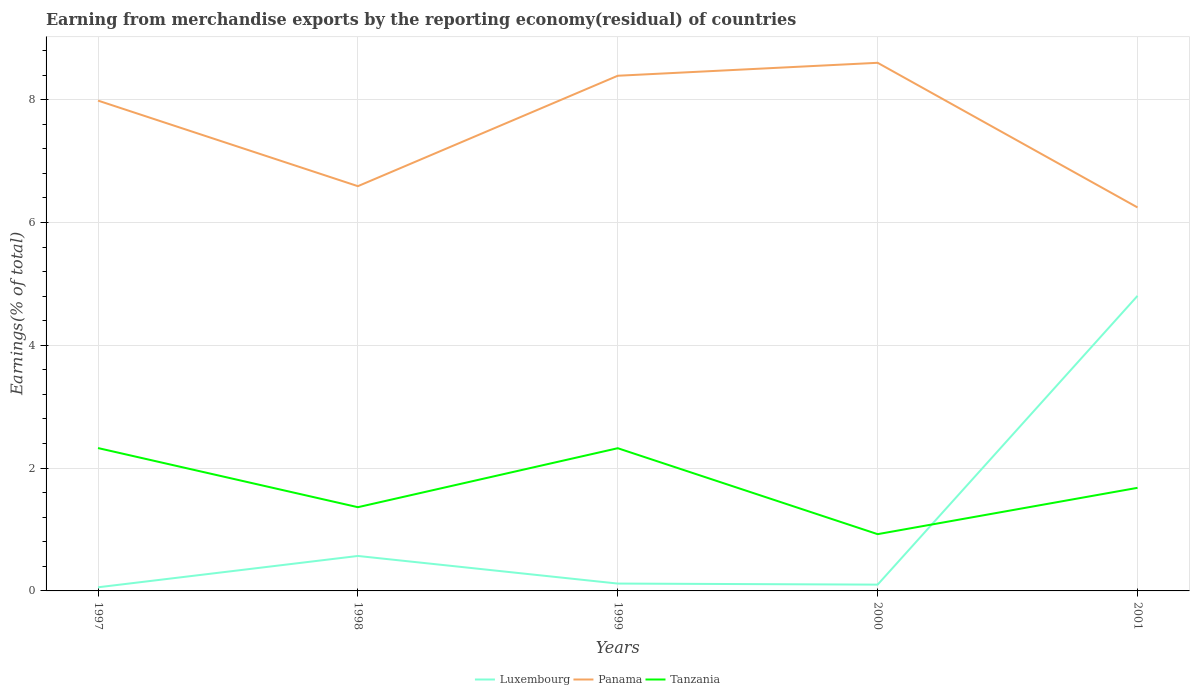Does the line corresponding to Panama intersect with the line corresponding to Tanzania?
Your answer should be very brief. No. Across all years, what is the maximum percentage of amount earned from merchandise exports in Luxembourg?
Give a very brief answer. 0.06. In which year was the percentage of amount earned from merchandise exports in Panama maximum?
Give a very brief answer. 2001. What is the total percentage of amount earned from merchandise exports in Panama in the graph?
Offer a terse response. 2.36. What is the difference between the highest and the second highest percentage of amount earned from merchandise exports in Tanzania?
Your answer should be compact. 1.4. What is the difference between the highest and the lowest percentage of amount earned from merchandise exports in Luxembourg?
Make the answer very short. 1. Is the percentage of amount earned from merchandise exports in Panama strictly greater than the percentage of amount earned from merchandise exports in Tanzania over the years?
Your response must be concise. No. Are the values on the major ticks of Y-axis written in scientific E-notation?
Provide a succinct answer. No. Does the graph contain any zero values?
Your answer should be compact. No. Where does the legend appear in the graph?
Give a very brief answer. Bottom center. What is the title of the graph?
Provide a succinct answer. Earning from merchandise exports by the reporting economy(residual) of countries. What is the label or title of the Y-axis?
Make the answer very short. Earnings(% of total). What is the Earnings(% of total) in Luxembourg in 1997?
Provide a short and direct response. 0.06. What is the Earnings(% of total) in Panama in 1997?
Provide a succinct answer. 7.99. What is the Earnings(% of total) of Tanzania in 1997?
Give a very brief answer. 2.33. What is the Earnings(% of total) of Luxembourg in 1998?
Ensure brevity in your answer.  0.57. What is the Earnings(% of total) of Panama in 1998?
Make the answer very short. 6.59. What is the Earnings(% of total) of Tanzania in 1998?
Make the answer very short. 1.36. What is the Earnings(% of total) in Luxembourg in 1999?
Keep it short and to the point. 0.12. What is the Earnings(% of total) of Panama in 1999?
Your answer should be very brief. 8.39. What is the Earnings(% of total) of Tanzania in 1999?
Your answer should be very brief. 2.32. What is the Earnings(% of total) in Luxembourg in 2000?
Offer a terse response. 0.1. What is the Earnings(% of total) of Panama in 2000?
Your response must be concise. 8.6. What is the Earnings(% of total) of Tanzania in 2000?
Make the answer very short. 0.92. What is the Earnings(% of total) of Luxembourg in 2001?
Your answer should be very brief. 4.81. What is the Earnings(% of total) of Panama in 2001?
Give a very brief answer. 6.25. What is the Earnings(% of total) in Tanzania in 2001?
Keep it short and to the point. 1.68. Across all years, what is the maximum Earnings(% of total) of Luxembourg?
Your answer should be very brief. 4.81. Across all years, what is the maximum Earnings(% of total) of Panama?
Your answer should be very brief. 8.6. Across all years, what is the maximum Earnings(% of total) of Tanzania?
Make the answer very short. 2.33. Across all years, what is the minimum Earnings(% of total) in Luxembourg?
Keep it short and to the point. 0.06. Across all years, what is the minimum Earnings(% of total) in Panama?
Your response must be concise. 6.25. Across all years, what is the minimum Earnings(% of total) of Tanzania?
Ensure brevity in your answer.  0.92. What is the total Earnings(% of total) of Luxembourg in the graph?
Your answer should be compact. 5.66. What is the total Earnings(% of total) in Panama in the graph?
Your response must be concise. 37.81. What is the total Earnings(% of total) of Tanzania in the graph?
Provide a short and direct response. 8.62. What is the difference between the Earnings(% of total) of Luxembourg in 1997 and that in 1998?
Ensure brevity in your answer.  -0.51. What is the difference between the Earnings(% of total) in Panama in 1997 and that in 1998?
Offer a very short reply. 1.39. What is the difference between the Earnings(% of total) in Tanzania in 1997 and that in 1998?
Your answer should be compact. 0.96. What is the difference between the Earnings(% of total) in Luxembourg in 1997 and that in 1999?
Your response must be concise. -0.06. What is the difference between the Earnings(% of total) of Panama in 1997 and that in 1999?
Offer a very short reply. -0.4. What is the difference between the Earnings(% of total) of Tanzania in 1997 and that in 1999?
Give a very brief answer. 0. What is the difference between the Earnings(% of total) in Luxembourg in 1997 and that in 2000?
Provide a short and direct response. -0.04. What is the difference between the Earnings(% of total) in Panama in 1997 and that in 2000?
Keep it short and to the point. -0.62. What is the difference between the Earnings(% of total) of Tanzania in 1997 and that in 2000?
Make the answer very short. 1.4. What is the difference between the Earnings(% of total) of Luxembourg in 1997 and that in 2001?
Your answer should be very brief. -4.75. What is the difference between the Earnings(% of total) in Panama in 1997 and that in 2001?
Your answer should be compact. 1.74. What is the difference between the Earnings(% of total) of Tanzania in 1997 and that in 2001?
Provide a succinct answer. 0.65. What is the difference between the Earnings(% of total) in Luxembourg in 1998 and that in 1999?
Your answer should be compact. 0.45. What is the difference between the Earnings(% of total) of Panama in 1998 and that in 1999?
Ensure brevity in your answer.  -1.8. What is the difference between the Earnings(% of total) of Tanzania in 1998 and that in 1999?
Your answer should be very brief. -0.96. What is the difference between the Earnings(% of total) of Luxembourg in 1998 and that in 2000?
Offer a very short reply. 0.47. What is the difference between the Earnings(% of total) of Panama in 1998 and that in 2000?
Offer a terse response. -2.01. What is the difference between the Earnings(% of total) in Tanzania in 1998 and that in 2000?
Offer a terse response. 0.44. What is the difference between the Earnings(% of total) of Luxembourg in 1998 and that in 2001?
Provide a succinct answer. -4.24. What is the difference between the Earnings(% of total) in Panama in 1998 and that in 2001?
Give a very brief answer. 0.35. What is the difference between the Earnings(% of total) of Tanzania in 1998 and that in 2001?
Offer a terse response. -0.32. What is the difference between the Earnings(% of total) in Luxembourg in 1999 and that in 2000?
Give a very brief answer. 0.02. What is the difference between the Earnings(% of total) of Panama in 1999 and that in 2000?
Your answer should be compact. -0.21. What is the difference between the Earnings(% of total) of Tanzania in 1999 and that in 2000?
Ensure brevity in your answer.  1.4. What is the difference between the Earnings(% of total) of Luxembourg in 1999 and that in 2001?
Provide a short and direct response. -4.69. What is the difference between the Earnings(% of total) in Panama in 1999 and that in 2001?
Make the answer very short. 2.14. What is the difference between the Earnings(% of total) in Tanzania in 1999 and that in 2001?
Offer a very short reply. 0.65. What is the difference between the Earnings(% of total) of Luxembourg in 2000 and that in 2001?
Give a very brief answer. -4.7. What is the difference between the Earnings(% of total) of Panama in 2000 and that in 2001?
Your answer should be very brief. 2.36. What is the difference between the Earnings(% of total) in Tanzania in 2000 and that in 2001?
Your answer should be very brief. -0.75. What is the difference between the Earnings(% of total) in Luxembourg in 1997 and the Earnings(% of total) in Panama in 1998?
Your answer should be compact. -6.53. What is the difference between the Earnings(% of total) in Luxembourg in 1997 and the Earnings(% of total) in Tanzania in 1998?
Ensure brevity in your answer.  -1.3. What is the difference between the Earnings(% of total) in Panama in 1997 and the Earnings(% of total) in Tanzania in 1998?
Your answer should be very brief. 6.62. What is the difference between the Earnings(% of total) of Luxembourg in 1997 and the Earnings(% of total) of Panama in 1999?
Provide a short and direct response. -8.33. What is the difference between the Earnings(% of total) in Luxembourg in 1997 and the Earnings(% of total) in Tanzania in 1999?
Offer a very short reply. -2.27. What is the difference between the Earnings(% of total) in Panama in 1997 and the Earnings(% of total) in Tanzania in 1999?
Your response must be concise. 5.66. What is the difference between the Earnings(% of total) in Luxembourg in 1997 and the Earnings(% of total) in Panama in 2000?
Give a very brief answer. -8.54. What is the difference between the Earnings(% of total) in Luxembourg in 1997 and the Earnings(% of total) in Tanzania in 2000?
Offer a terse response. -0.87. What is the difference between the Earnings(% of total) in Panama in 1997 and the Earnings(% of total) in Tanzania in 2000?
Give a very brief answer. 7.06. What is the difference between the Earnings(% of total) of Luxembourg in 1997 and the Earnings(% of total) of Panama in 2001?
Offer a terse response. -6.19. What is the difference between the Earnings(% of total) of Luxembourg in 1997 and the Earnings(% of total) of Tanzania in 2001?
Ensure brevity in your answer.  -1.62. What is the difference between the Earnings(% of total) in Panama in 1997 and the Earnings(% of total) in Tanzania in 2001?
Your answer should be very brief. 6.31. What is the difference between the Earnings(% of total) of Luxembourg in 1998 and the Earnings(% of total) of Panama in 1999?
Ensure brevity in your answer.  -7.82. What is the difference between the Earnings(% of total) in Luxembourg in 1998 and the Earnings(% of total) in Tanzania in 1999?
Give a very brief answer. -1.75. What is the difference between the Earnings(% of total) in Panama in 1998 and the Earnings(% of total) in Tanzania in 1999?
Your answer should be very brief. 4.27. What is the difference between the Earnings(% of total) of Luxembourg in 1998 and the Earnings(% of total) of Panama in 2000?
Ensure brevity in your answer.  -8.03. What is the difference between the Earnings(% of total) in Luxembourg in 1998 and the Earnings(% of total) in Tanzania in 2000?
Make the answer very short. -0.36. What is the difference between the Earnings(% of total) of Panama in 1998 and the Earnings(% of total) of Tanzania in 2000?
Offer a very short reply. 5.67. What is the difference between the Earnings(% of total) of Luxembourg in 1998 and the Earnings(% of total) of Panama in 2001?
Your answer should be very brief. -5.68. What is the difference between the Earnings(% of total) of Luxembourg in 1998 and the Earnings(% of total) of Tanzania in 2001?
Ensure brevity in your answer.  -1.11. What is the difference between the Earnings(% of total) in Panama in 1998 and the Earnings(% of total) in Tanzania in 2001?
Keep it short and to the point. 4.91. What is the difference between the Earnings(% of total) of Luxembourg in 1999 and the Earnings(% of total) of Panama in 2000?
Your response must be concise. -8.48. What is the difference between the Earnings(% of total) of Luxembourg in 1999 and the Earnings(% of total) of Tanzania in 2000?
Provide a short and direct response. -0.8. What is the difference between the Earnings(% of total) in Panama in 1999 and the Earnings(% of total) in Tanzania in 2000?
Ensure brevity in your answer.  7.47. What is the difference between the Earnings(% of total) of Luxembourg in 1999 and the Earnings(% of total) of Panama in 2001?
Your answer should be very brief. -6.13. What is the difference between the Earnings(% of total) of Luxembourg in 1999 and the Earnings(% of total) of Tanzania in 2001?
Ensure brevity in your answer.  -1.56. What is the difference between the Earnings(% of total) of Panama in 1999 and the Earnings(% of total) of Tanzania in 2001?
Offer a very short reply. 6.71. What is the difference between the Earnings(% of total) in Luxembourg in 2000 and the Earnings(% of total) in Panama in 2001?
Your response must be concise. -6.14. What is the difference between the Earnings(% of total) in Luxembourg in 2000 and the Earnings(% of total) in Tanzania in 2001?
Provide a short and direct response. -1.58. What is the difference between the Earnings(% of total) of Panama in 2000 and the Earnings(% of total) of Tanzania in 2001?
Offer a very short reply. 6.92. What is the average Earnings(% of total) in Luxembourg per year?
Provide a succinct answer. 1.13. What is the average Earnings(% of total) of Panama per year?
Make the answer very short. 7.56. What is the average Earnings(% of total) in Tanzania per year?
Provide a succinct answer. 1.72. In the year 1997, what is the difference between the Earnings(% of total) in Luxembourg and Earnings(% of total) in Panama?
Give a very brief answer. -7.93. In the year 1997, what is the difference between the Earnings(% of total) of Luxembourg and Earnings(% of total) of Tanzania?
Provide a short and direct response. -2.27. In the year 1997, what is the difference between the Earnings(% of total) of Panama and Earnings(% of total) of Tanzania?
Give a very brief answer. 5.66. In the year 1998, what is the difference between the Earnings(% of total) of Luxembourg and Earnings(% of total) of Panama?
Your response must be concise. -6.02. In the year 1998, what is the difference between the Earnings(% of total) of Luxembourg and Earnings(% of total) of Tanzania?
Offer a terse response. -0.79. In the year 1998, what is the difference between the Earnings(% of total) in Panama and Earnings(% of total) in Tanzania?
Your response must be concise. 5.23. In the year 1999, what is the difference between the Earnings(% of total) of Luxembourg and Earnings(% of total) of Panama?
Your response must be concise. -8.27. In the year 1999, what is the difference between the Earnings(% of total) in Luxembourg and Earnings(% of total) in Tanzania?
Keep it short and to the point. -2.2. In the year 1999, what is the difference between the Earnings(% of total) of Panama and Earnings(% of total) of Tanzania?
Your response must be concise. 6.07. In the year 2000, what is the difference between the Earnings(% of total) of Luxembourg and Earnings(% of total) of Panama?
Provide a short and direct response. -8.5. In the year 2000, what is the difference between the Earnings(% of total) of Luxembourg and Earnings(% of total) of Tanzania?
Offer a terse response. -0.82. In the year 2000, what is the difference between the Earnings(% of total) in Panama and Earnings(% of total) in Tanzania?
Give a very brief answer. 7.68. In the year 2001, what is the difference between the Earnings(% of total) in Luxembourg and Earnings(% of total) in Panama?
Ensure brevity in your answer.  -1.44. In the year 2001, what is the difference between the Earnings(% of total) of Luxembourg and Earnings(% of total) of Tanzania?
Your answer should be very brief. 3.13. In the year 2001, what is the difference between the Earnings(% of total) of Panama and Earnings(% of total) of Tanzania?
Give a very brief answer. 4.57. What is the ratio of the Earnings(% of total) of Luxembourg in 1997 to that in 1998?
Your answer should be compact. 0.1. What is the ratio of the Earnings(% of total) in Panama in 1997 to that in 1998?
Offer a terse response. 1.21. What is the ratio of the Earnings(% of total) of Tanzania in 1997 to that in 1998?
Offer a terse response. 1.71. What is the ratio of the Earnings(% of total) of Luxembourg in 1997 to that in 1999?
Provide a short and direct response. 0.49. What is the ratio of the Earnings(% of total) in Panama in 1997 to that in 1999?
Your answer should be compact. 0.95. What is the ratio of the Earnings(% of total) in Tanzania in 1997 to that in 1999?
Offer a very short reply. 1. What is the ratio of the Earnings(% of total) of Luxembourg in 1997 to that in 2000?
Your response must be concise. 0.58. What is the ratio of the Earnings(% of total) in Panama in 1997 to that in 2000?
Your response must be concise. 0.93. What is the ratio of the Earnings(% of total) in Tanzania in 1997 to that in 2000?
Give a very brief answer. 2.52. What is the ratio of the Earnings(% of total) of Luxembourg in 1997 to that in 2001?
Ensure brevity in your answer.  0.01. What is the ratio of the Earnings(% of total) in Panama in 1997 to that in 2001?
Provide a succinct answer. 1.28. What is the ratio of the Earnings(% of total) in Tanzania in 1997 to that in 2001?
Provide a short and direct response. 1.39. What is the ratio of the Earnings(% of total) in Luxembourg in 1998 to that in 1999?
Offer a very short reply. 4.75. What is the ratio of the Earnings(% of total) in Panama in 1998 to that in 1999?
Your answer should be very brief. 0.79. What is the ratio of the Earnings(% of total) of Tanzania in 1998 to that in 1999?
Give a very brief answer. 0.59. What is the ratio of the Earnings(% of total) of Luxembourg in 1998 to that in 2000?
Your response must be concise. 5.56. What is the ratio of the Earnings(% of total) in Panama in 1998 to that in 2000?
Offer a terse response. 0.77. What is the ratio of the Earnings(% of total) of Tanzania in 1998 to that in 2000?
Offer a terse response. 1.48. What is the ratio of the Earnings(% of total) of Luxembourg in 1998 to that in 2001?
Ensure brevity in your answer.  0.12. What is the ratio of the Earnings(% of total) in Panama in 1998 to that in 2001?
Keep it short and to the point. 1.06. What is the ratio of the Earnings(% of total) in Tanzania in 1998 to that in 2001?
Your answer should be compact. 0.81. What is the ratio of the Earnings(% of total) in Luxembourg in 1999 to that in 2000?
Make the answer very short. 1.17. What is the ratio of the Earnings(% of total) in Panama in 1999 to that in 2000?
Your answer should be very brief. 0.98. What is the ratio of the Earnings(% of total) in Tanzania in 1999 to that in 2000?
Keep it short and to the point. 2.51. What is the ratio of the Earnings(% of total) in Luxembourg in 1999 to that in 2001?
Provide a succinct answer. 0.02. What is the ratio of the Earnings(% of total) in Panama in 1999 to that in 2001?
Your answer should be very brief. 1.34. What is the ratio of the Earnings(% of total) in Tanzania in 1999 to that in 2001?
Provide a succinct answer. 1.38. What is the ratio of the Earnings(% of total) of Luxembourg in 2000 to that in 2001?
Keep it short and to the point. 0.02. What is the ratio of the Earnings(% of total) of Panama in 2000 to that in 2001?
Ensure brevity in your answer.  1.38. What is the ratio of the Earnings(% of total) of Tanzania in 2000 to that in 2001?
Provide a short and direct response. 0.55. What is the difference between the highest and the second highest Earnings(% of total) of Luxembourg?
Offer a very short reply. 4.24. What is the difference between the highest and the second highest Earnings(% of total) of Panama?
Give a very brief answer. 0.21. What is the difference between the highest and the second highest Earnings(% of total) in Tanzania?
Ensure brevity in your answer.  0. What is the difference between the highest and the lowest Earnings(% of total) in Luxembourg?
Keep it short and to the point. 4.75. What is the difference between the highest and the lowest Earnings(% of total) in Panama?
Your answer should be compact. 2.36. What is the difference between the highest and the lowest Earnings(% of total) of Tanzania?
Your response must be concise. 1.4. 